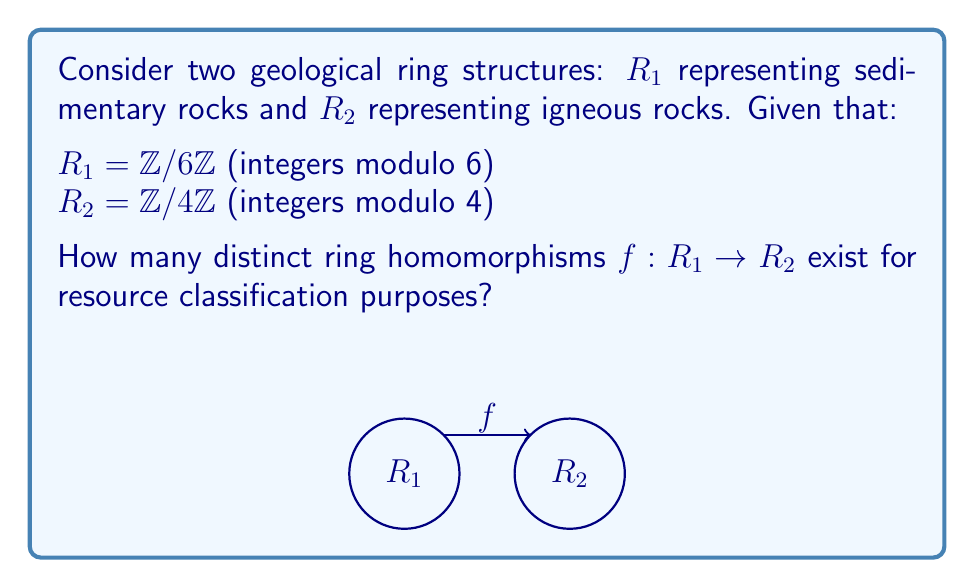Can you solve this math problem? To determine the number of distinct ring homomorphisms from $R_1$ to $R_2$, we follow these steps:

1) A ring homomorphism must preserve addition and multiplication, and map the identity element of $R_1$ to the identity element of $R_2$.

2) In $R_1$, the identity element is $[0]_6$. In $R_2$, it's $[0]_4$. So, $f([0]_6) = [0]_4$.

3) The key property of a ring homomorphism is that it's completely determined by where it sends the generator of $R_1$. In this case, the generator is $[1]_6$.

4) $f([1]_6)$ must satisfy the equation $6f([1]_6) = f(6[1]_6) = f([0]_6) = [0]_4$ in $R_2$.

5) In $R_2 = \mathbb{Z}/4\mathbb{Z}$, the only element that satisfies this equation is $[0]_4$.

6) Therefore, there is only one possible homomorphism, defined by:
   $f([1]_6) = [0]_4$

7) This completely determines the homomorphism:
   $f([0]_6) = [0]_4$
   $f([1]_6) = [0]_4$
   $f([2]_6) = [0]_4$
   $f([3]_6) = [0]_4$
   $f([4]_6) = [0]_4$
   $f([5]_6) = [0]_4$

8) This homomorphism maps all elements of $R_1$ to the zero element of $R_2$, which is known as the zero homomorphism.
Answer: 1 (the zero homomorphism) 